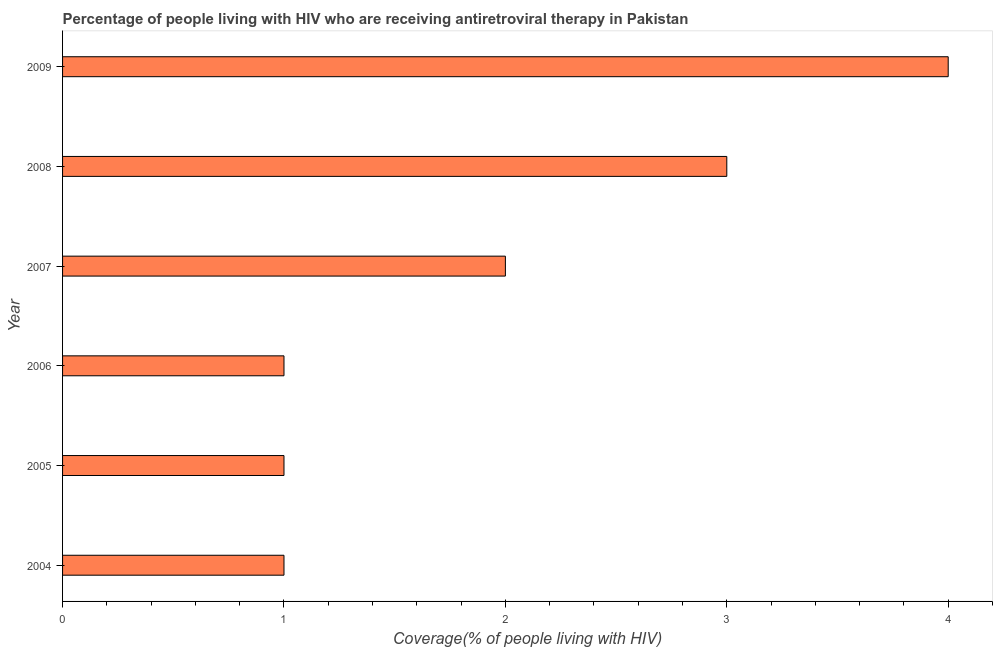Does the graph contain any zero values?
Provide a succinct answer. No. Does the graph contain grids?
Your answer should be very brief. No. What is the title of the graph?
Your answer should be very brief. Percentage of people living with HIV who are receiving antiretroviral therapy in Pakistan. What is the label or title of the X-axis?
Offer a very short reply. Coverage(% of people living with HIV). What is the antiretroviral therapy coverage in 2008?
Your response must be concise. 3. Across all years, what is the minimum antiretroviral therapy coverage?
Make the answer very short. 1. In which year was the antiretroviral therapy coverage minimum?
Make the answer very short. 2004. What is the difference between the antiretroviral therapy coverage in 2006 and 2008?
Your response must be concise. -2. Do a majority of the years between 2006 and 2004 (inclusive) have antiretroviral therapy coverage greater than 2.2 %?
Offer a terse response. Yes. What is the ratio of the antiretroviral therapy coverage in 2006 to that in 2008?
Provide a short and direct response. 0.33. Is the antiretroviral therapy coverage in 2004 less than that in 2009?
Keep it short and to the point. Yes. Is the sum of the antiretroviral therapy coverage in 2005 and 2008 greater than the maximum antiretroviral therapy coverage across all years?
Provide a short and direct response. No. What is the difference between the highest and the lowest antiretroviral therapy coverage?
Keep it short and to the point. 3. In how many years, is the antiretroviral therapy coverage greater than the average antiretroviral therapy coverage taken over all years?
Make the answer very short. 2. How many bars are there?
Make the answer very short. 6. How many years are there in the graph?
Give a very brief answer. 6. What is the difference between two consecutive major ticks on the X-axis?
Your answer should be very brief. 1. What is the Coverage(% of people living with HIV) of 2004?
Offer a very short reply. 1. What is the Coverage(% of people living with HIV) of 2005?
Your answer should be compact. 1. What is the Coverage(% of people living with HIV) in 2008?
Provide a succinct answer. 3. What is the Coverage(% of people living with HIV) in 2009?
Your response must be concise. 4. What is the difference between the Coverage(% of people living with HIV) in 2004 and 2006?
Make the answer very short. 0. What is the difference between the Coverage(% of people living with HIV) in 2004 and 2007?
Ensure brevity in your answer.  -1. What is the difference between the Coverage(% of people living with HIV) in 2004 and 2009?
Your answer should be compact. -3. What is the difference between the Coverage(% of people living with HIV) in 2005 and 2007?
Offer a very short reply. -1. What is the difference between the Coverage(% of people living with HIV) in 2005 and 2008?
Offer a very short reply. -2. What is the difference between the Coverage(% of people living with HIV) in 2006 and 2007?
Offer a very short reply. -1. What is the difference between the Coverage(% of people living with HIV) in 2006 and 2009?
Your answer should be compact. -3. What is the difference between the Coverage(% of people living with HIV) in 2007 and 2008?
Offer a terse response. -1. What is the difference between the Coverage(% of people living with HIV) in 2007 and 2009?
Your answer should be very brief. -2. What is the difference between the Coverage(% of people living with HIV) in 2008 and 2009?
Make the answer very short. -1. What is the ratio of the Coverage(% of people living with HIV) in 2004 to that in 2006?
Provide a succinct answer. 1. What is the ratio of the Coverage(% of people living with HIV) in 2004 to that in 2007?
Offer a terse response. 0.5. What is the ratio of the Coverage(% of people living with HIV) in 2004 to that in 2008?
Your answer should be very brief. 0.33. What is the ratio of the Coverage(% of people living with HIV) in 2005 to that in 2006?
Your response must be concise. 1. What is the ratio of the Coverage(% of people living with HIV) in 2005 to that in 2007?
Your answer should be very brief. 0.5. What is the ratio of the Coverage(% of people living with HIV) in 2005 to that in 2008?
Provide a short and direct response. 0.33. What is the ratio of the Coverage(% of people living with HIV) in 2006 to that in 2007?
Your response must be concise. 0.5. What is the ratio of the Coverage(% of people living with HIV) in 2006 to that in 2008?
Make the answer very short. 0.33. What is the ratio of the Coverage(% of people living with HIV) in 2007 to that in 2008?
Your answer should be very brief. 0.67. What is the ratio of the Coverage(% of people living with HIV) in 2007 to that in 2009?
Your response must be concise. 0.5. 